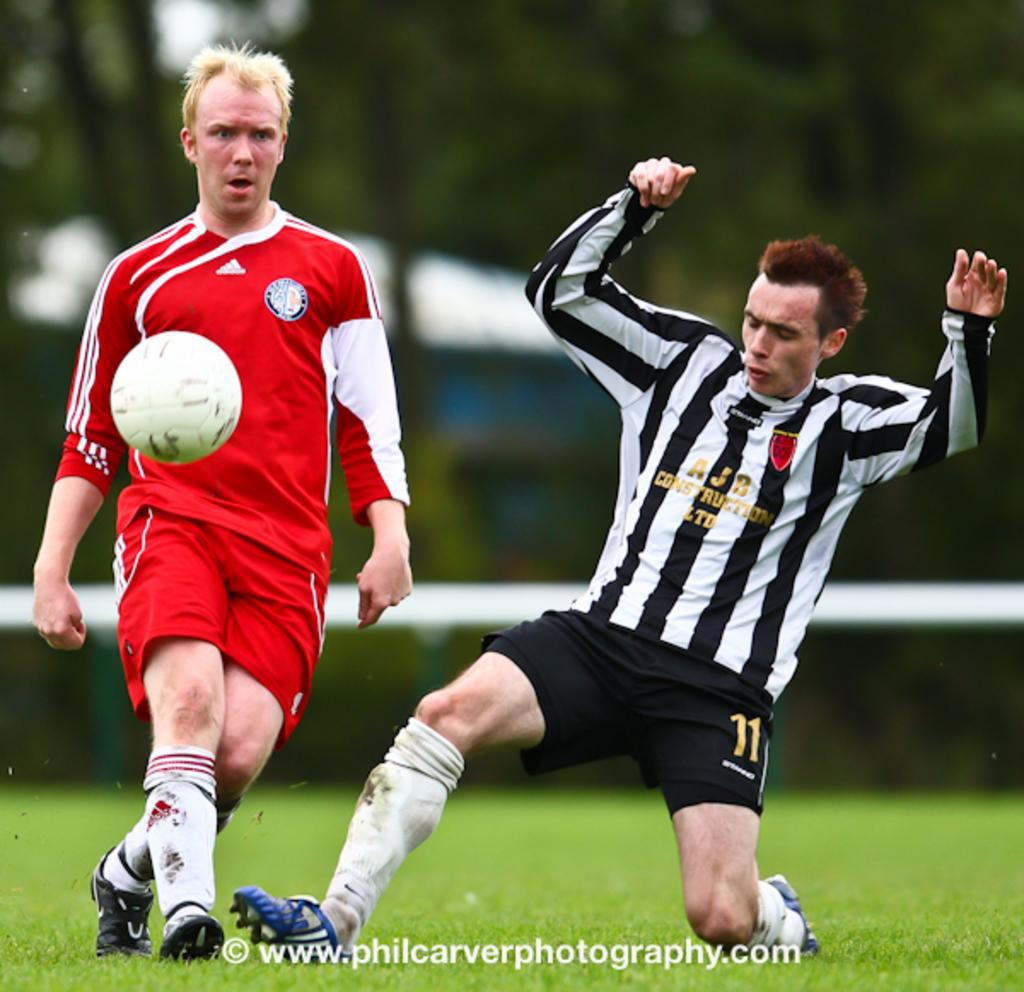<image>
Summarize the visual content of the image. A soccer player has the number 11 on his shorts. 